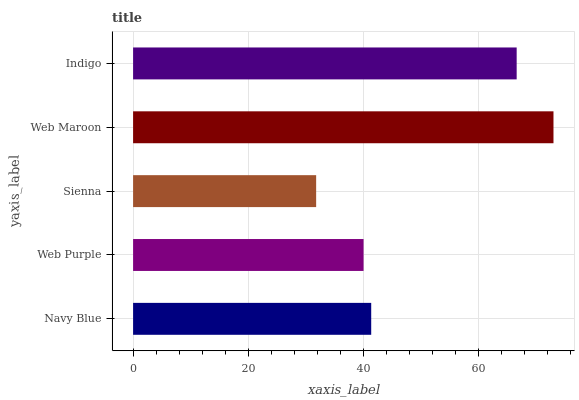Is Sienna the minimum?
Answer yes or no. Yes. Is Web Maroon the maximum?
Answer yes or no. Yes. Is Web Purple the minimum?
Answer yes or no. No. Is Web Purple the maximum?
Answer yes or no. No. Is Navy Blue greater than Web Purple?
Answer yes or no. Yes. Is Web Purple less than Navy Blue?
Answer yes or no. Yes. Is Web Purple greater than Navy Blue?
Answer yes or no. No. Is Navy Blue less than Web Purple?
Answer yes or no. No. Is Navy Blue the high median?
Answer yes or no. Yes. Is Navy Blue the low median?
Answer yes or no. Yes. Is Sienna the high median?
Answer yes or no. No. Is Indigo the low median?
Answer yes or no. No. 